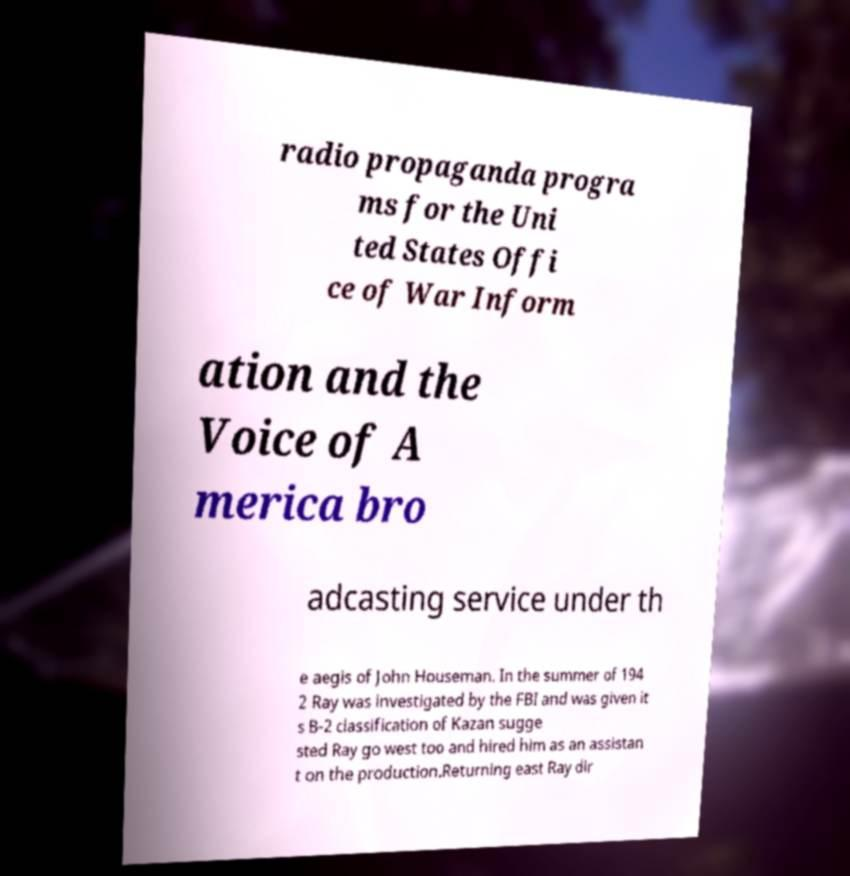Please read and relay the text visible in this image. What does it say? radio propaganda progra ms for the Uni ted States Offi ce of War Inform ation and the Voice of A merica bro adcasting service under th e aegis of John Houseman. In the summer of 194 2 Ray was investigated by the FBI and was given it s B-2 classification of Kazan sugge sted Ray go west too and hired him as an assistan t on the production.Returning east Ray dir 